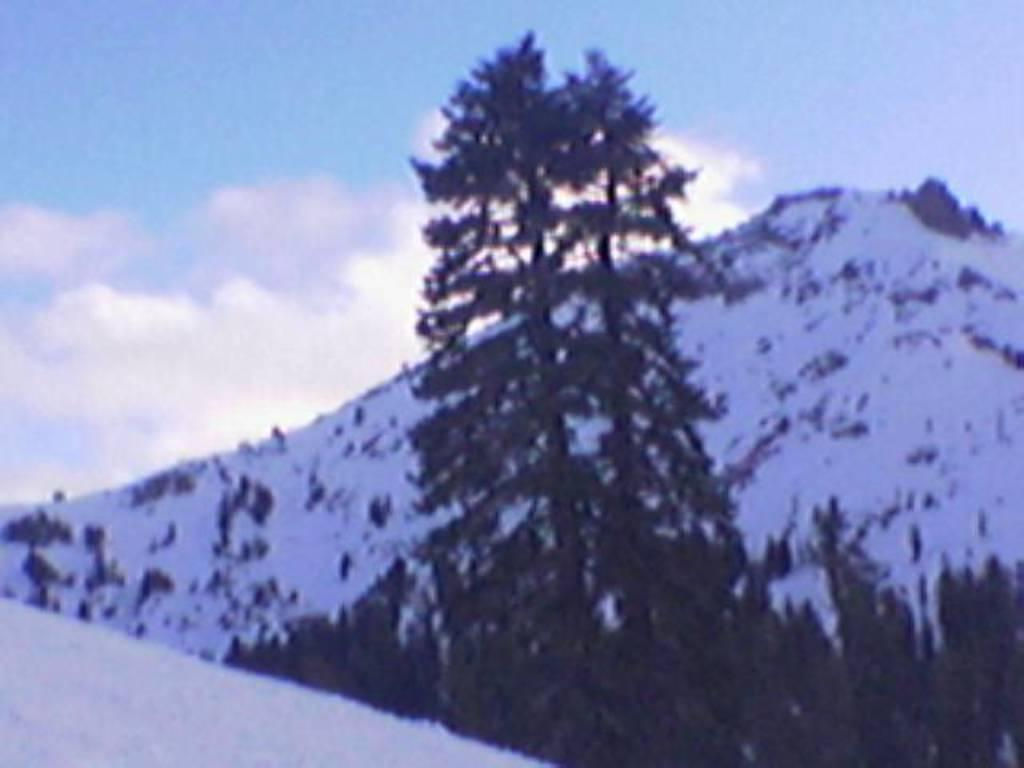What is the main feature of the image? There is an ice hill in the image. What other natural elements can be seen in the image? There are trees in the image. What is visible in the background of the image? The sky is visible in the image. How would you describe the weather based on the sky in the image? The sky appears to be cloudy in the image. How many ducks are sitting on the rock in the image? There are no ducks or rocks present in the image. What type of lizards can be seen climbing the ice hill in the image? There are no lizards visible in the image. 